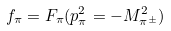Convert formula to latex. <formula><loc_0><loc_0><loc_500><loc_500>f _ { \pi } = F _ { \pi } ( p _ { \pi } ^ { 2 } = - M _ { \pi ^ { \pm } } ^ { 2 } )</formula> 